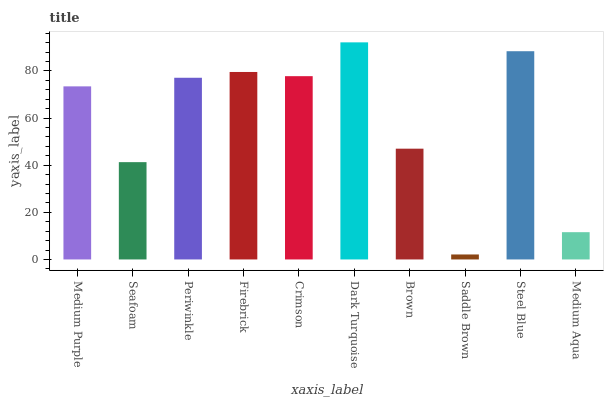Is Saddle Brown the minimum?
Answer yes or no. Yes. Is Dark Turquoise the maximum?
Answer yes or no. Yes. Is Seafoam the minimum?
Answer yes or no. No. Is Seafoam the maximum?
Answer yes or no. No. Is Medium Purple greater than Seafoam?
Answer yes or no. Yes. Is Seafoam less than Medium Purple?
Answer yes or no. Yes. Is Seafoam greater than Medium Purple?
Answer yes or no. No. Is Medium Purple less than Seafoam?
Answer yes or no. No. Is Periwinkle the high median?
Answer yes or no. Yes. Is Medium Purple the low median?
Answer yes or no. Yes. Is Brown the high median?
Answer yes or no. No. Is Dark Turquoise the low median?
Answer yes or no. No. 